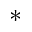Convert formula to latex. <formula><loc_0><loc_0><loc_500><loc_500>^ { * }</formula> 